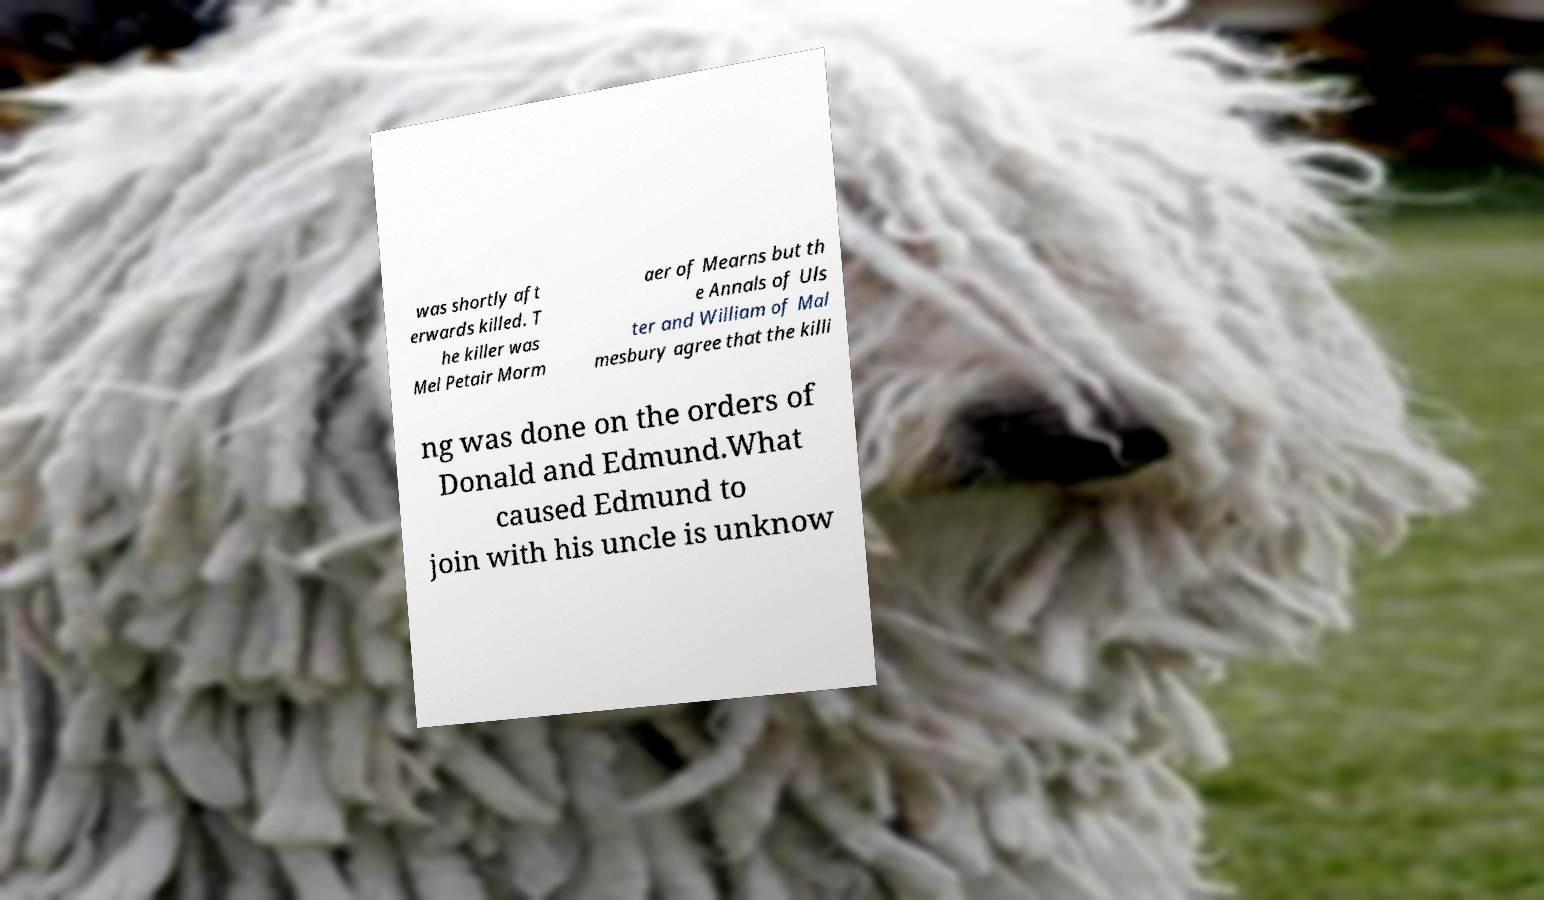Please read and relay the text visible in this image. What does it say? was shortly aft erwards killed. T he killer was Mel Petair Morm aer of Mearns but th e Annals of Uls ter and William of Mal mesbury agree that the killi ng was done on the orders of Donald and Edmund.What caused Edmund to join with his uncle is unknow 